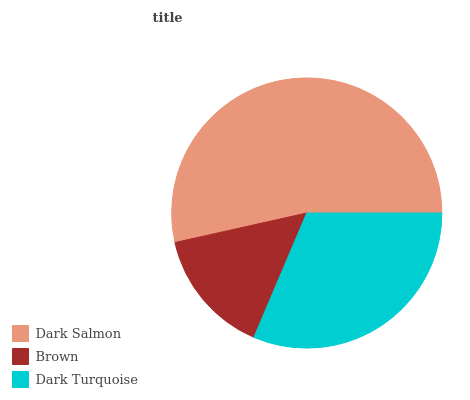Is Brown the minimum?
Answer yes or no. Yes. Is Dark Salmon the maximum?
Answer yes or no. Yes. Is Dark Turquoise the minimum?
Answer yes or no. No. Is Dark Turquoise the maximum?
Answer yes or no. No. Is Dark Turquoise greater than Brown?
Answer yes or no. Yes. Is Brown less than Dark Turquoise?
Answer yes or no. Yes. Is Brown greater than Dark Turquoise?
Answer yes or no. No. Is Dark Turquoise less than Brown?
Answer yes or no. No. Is Dark Turquoise the high median?
Answer yes or no. Yes. Is Dark Turquoise the low median?
Answer yes or no. Yes. Is Dark Salmon the high median?
Answer yes or no. No. Is Brown the low median?
Answer yes or no. No. 